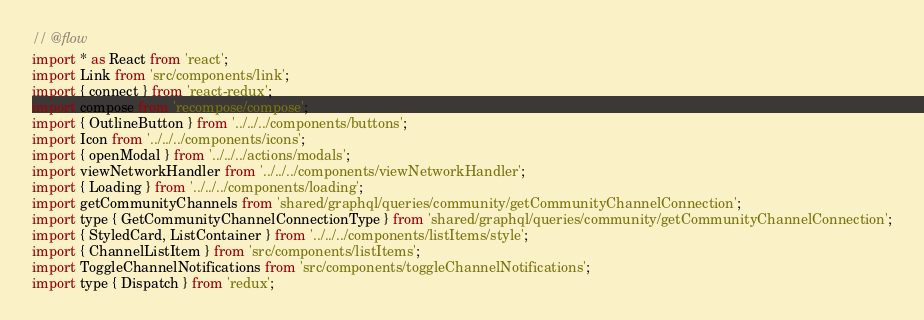<code> <loc_0><loc_0><loc_500><loc_500><_JavaScript_>// @flow
import * as React from 'react';
import Link from 'src/components/link';
import { connect } from 'react-redux';
import compose from 'recompose/compose';
import { OutlineButton } from '../../../components/buttons';
import Icon from '../../../components/icons';
import { openModal } from '../../../actions/modals';
import viewNetworkHandler from '../../../components/viewNetworkHandler';
import { Loading } from '../../../components/loading';
import getCommunityChannels from 'shared/graphql/queries/community/getCommunityChannelConnection';
import type { GetCommunityChannelConnectionType } from 'shared/graphql/queries/community/getCommunityChannelConnection';
import { StyledCard, ListContainer } from '../../../components/listItems/style';
import { ChannelListItem } from 'src/components/listItems';
import ToggleChannelNotifications from 'src/components/toggleChannelNotifications';
import type { Dispatch } from 'redux';</code> 